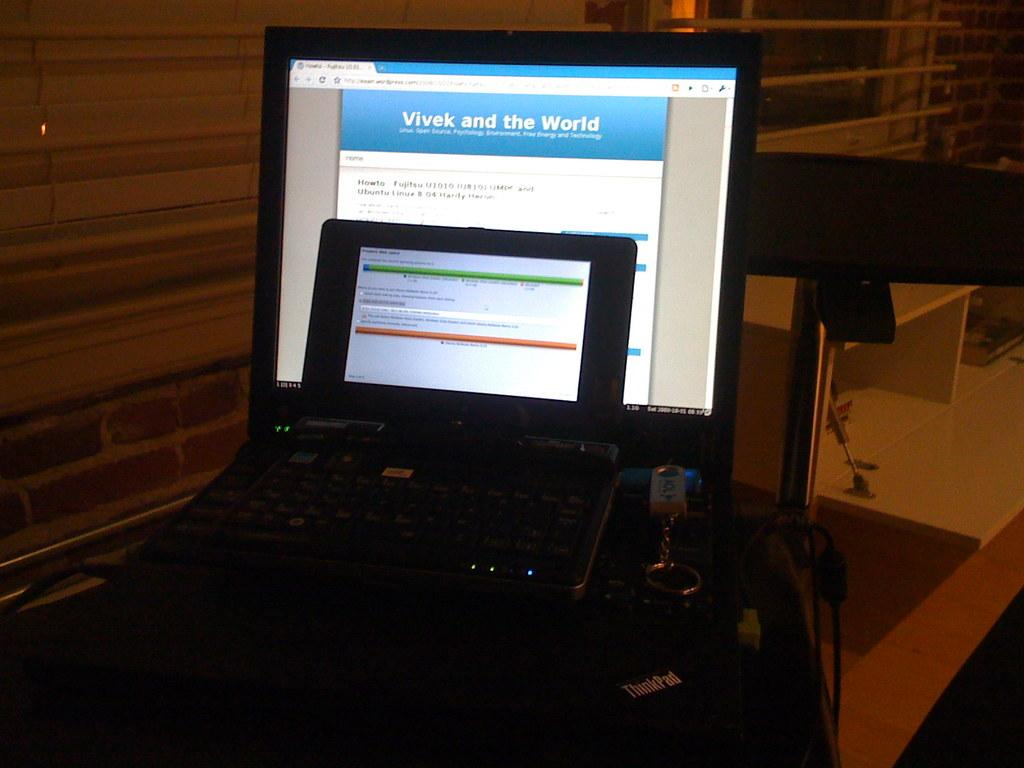Provide a one-sentence caption for the provided image. A computer screen with a web page opened that is titled Vivek and the World. 